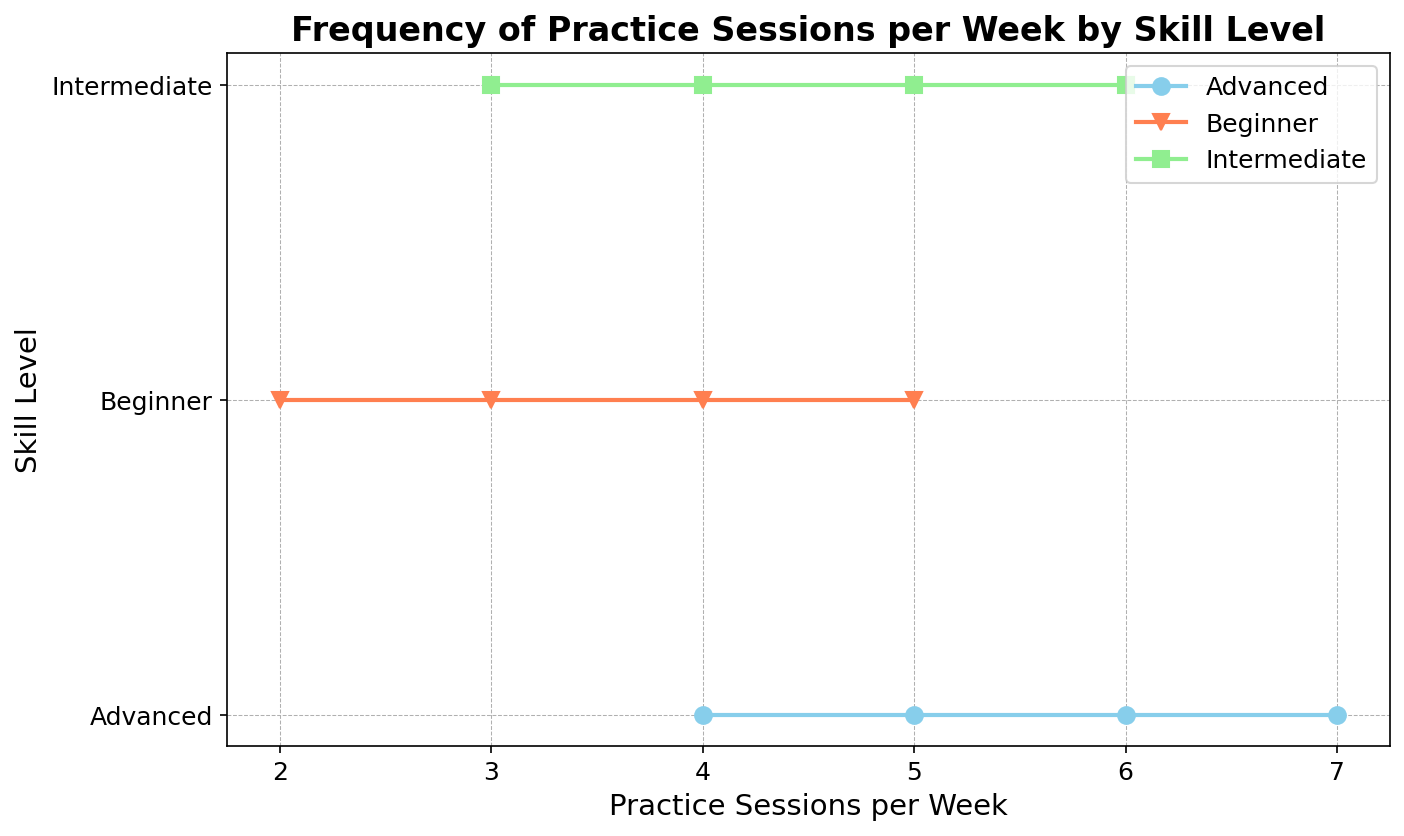What's the range of practice sessions per week for Intermediate skill level? To find the range of practice sessions per week for the Intermediate level, we look at the smallest and largest values in that category. The Intermediate level has data points at 3, 4, 5, and 6 practice sessions per week. The range is calculated as the difference between the largest and smallest values, which is 6 - 3.
Answer: 3 Which skill level has the most variation in practice sessions per week? To determine which skill level has the most variation, we need to compare the range of practice sessions for each skill level. The Beginners range from 2 to 5 sessions (3 sessions), Intermediates range from 3 to 6 sessions (3 sessions), and Advanced range from 4 to 7 sessions (3 sessions). Since all skill levels have the same range, the variation is equal across all three skill levels.
Answer: All How many practice sessions per week are common to both Intermediate and Advanced levels? To find common practice sessions per week between Intermediate and Advanced levels, we need to look at the overlapping values. Intermediates have 3, 4, 5, and 6 sessions, and Advanced have 4, 5, 6, and 7 sessions. The common values are 4, 5, and 6.
Answer: 3 What is the median practice session frequency for the Beginner skill level? The median is the middle value when the data points are ordered. For Beginners, the practice sessions are 2, 3, 4, and 5. When ordered: 2, 3, 4, and 5. Since there are 4 values, the median will be the average of the two middlemost values: (3 + 4) / 2 = 3.5.
Answer: 3.5 Between Intermediate and Advanced skill levels, which requires more minimum practice sessions per week? To compare the minimum practice sessions, we look at the smallest values in each category. Intermediate's minimum is 3 sessions per week, and Advanced's minimum is 4 sessions per week. Thus, Advanced requires more minimum practice sessions per week.
Answer: Advanced What color represents the Advanced skill level in the plot? To determine the color representing the Advanced skill level, we look at the information provided about the plot. The colors assigned to each skill level are: skyblue for Beginners, coral for Intermediates, and lightgreen for Advanced. Therefore, lightgreen represents Advanced skill level.
Answer: lightgreen How many total practice sessions are recorded for the Beginner skill level? We sum up all the practice sessions recorded for Beginners: 2, 3, 4, and 5. Thus, the total is 2 + 3 + 4 + 5 = 14.
Answer: 14 Which skill level has the highest number of different practice session frequencies? To find this, we count the number of unique practice session frequencies for each skill level. Beginners have 4 (2, 3, 4, and 5), Intermediates have 4 (3, 4, 5, and 6), and Advanced have 4 (4, 5, 6, and 7). They all have the same number, 4.
Answer: All 